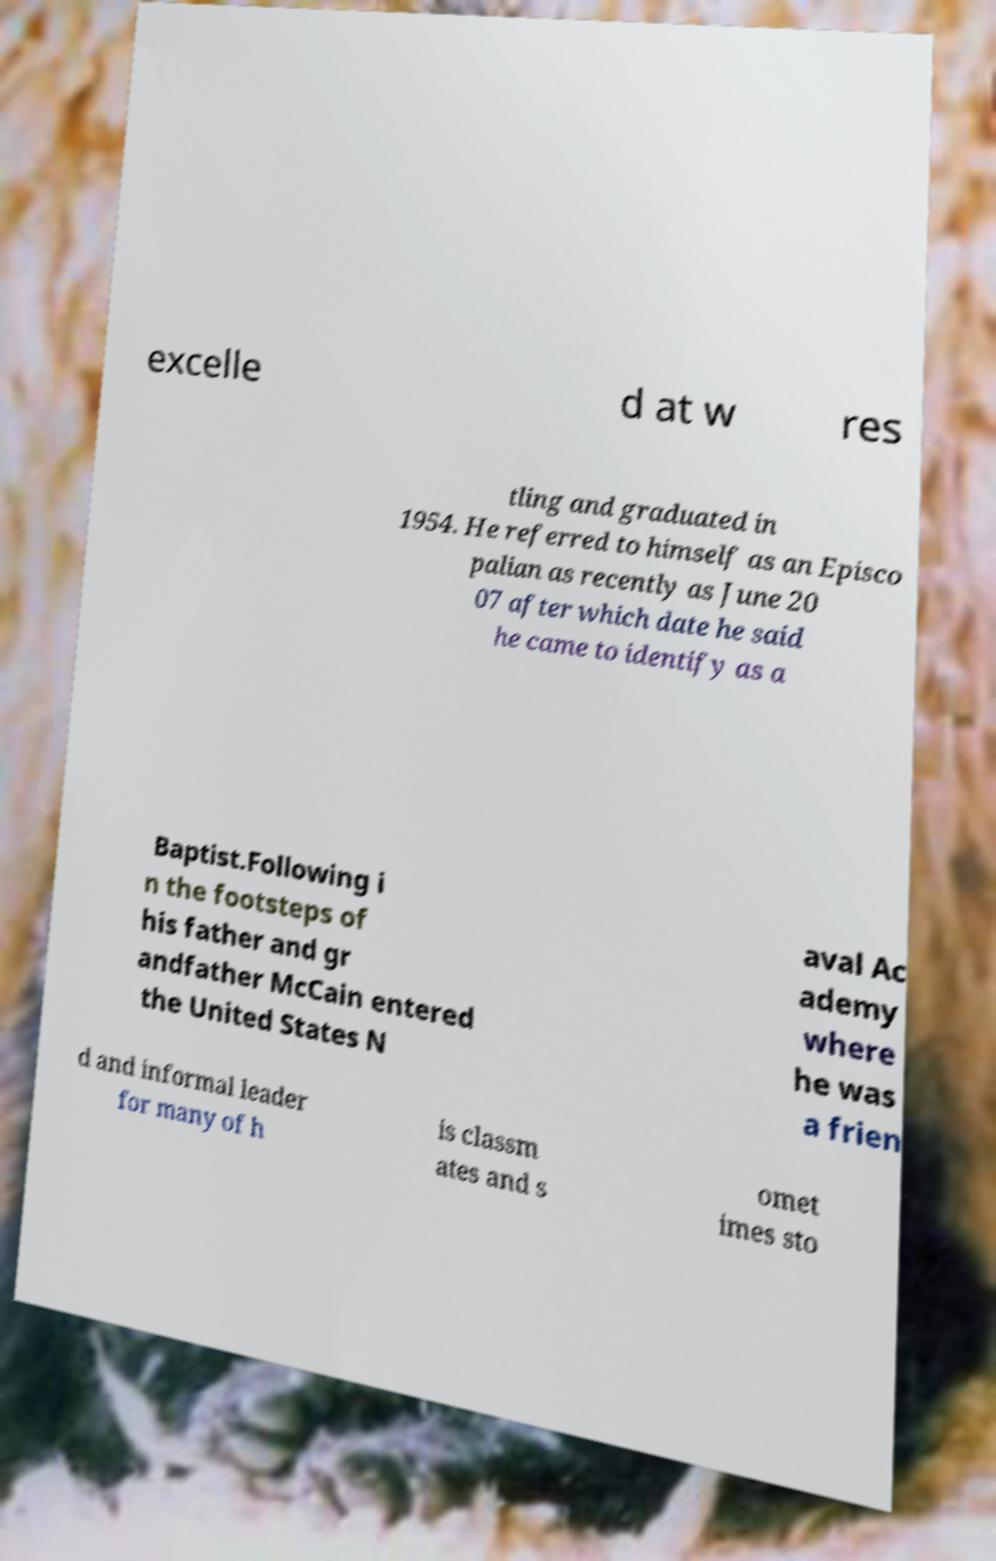Can you read and provide the text displayed in the image?This photo seems to have some interesting text. Can you extract and type it out for me? excelle d at w res tling and graduated in 1954. He referred to himself as an Episco palian as recently as June 20 07 after which date he said he came to identify as a Baptist.Following i n the footsteps of his father and gr andfather McCain entered the United States N aval Ac ademy where he was a frien d and informal leader for many of h is classm ates and s omet imes sto 